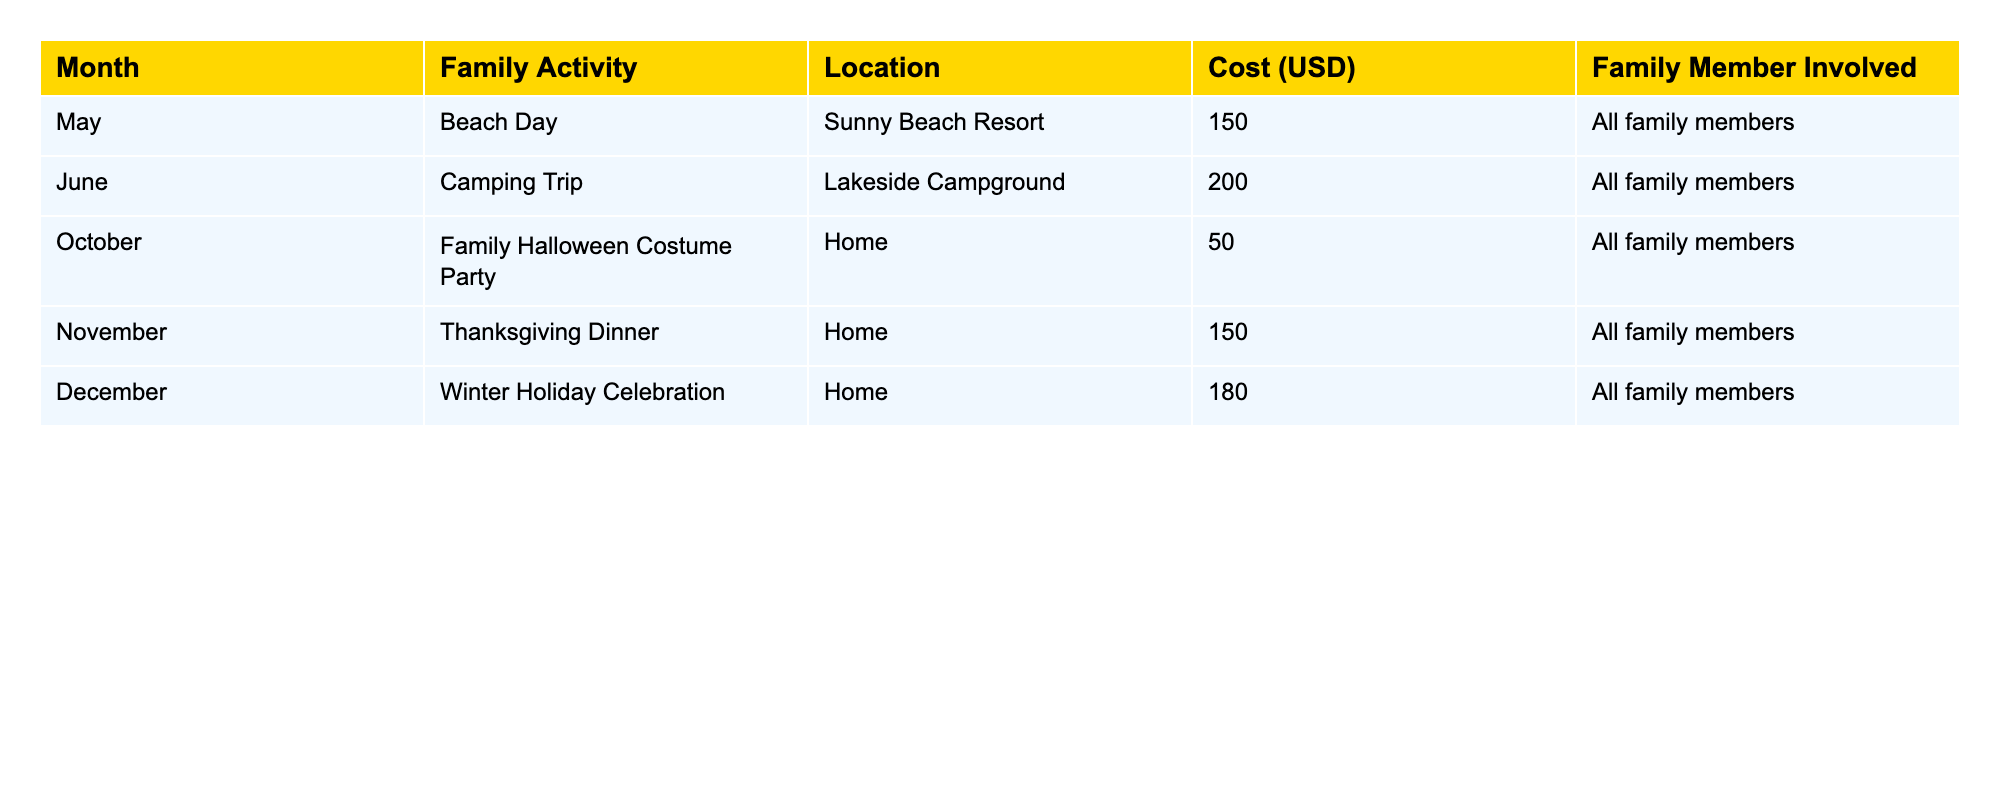What was the cost of the Camping Trip in June? The table indicates the activity for June is "Camping Trip" and the corresponding cost listed is 200 USD.
Answer: 200 USD Which family activity had the lowest cost? The activities and their costs are compared: Beach Day (150 USD), Camping Trip (200 USD), Halloween Costume Party (50 USD), Thanksgiving Dinner (150 USD), and Winter Holiday Celebration (180 USD). The lowest cost is 50 USD for the Halloween Costume Party.
Answer: Halloween Costume Party How much did the family spend in total for the activities in 2023? The individual costs of each activity are summed: 150 + 200 + 50 + 150 + 180 = 730 USD. This is the total expense for the year.
Answer: 730 USD Was there any family activity in December? Yes, according to the table, there is a "Winter Holiday Celebration" listed under December, confirming the existence of a family activity that month.
Answer: Yes What is the average cost of the family activities? To find the average, the total cost is 730 USD (from previous calculation) divided by the number of activities (5), resulting in 730/5 = 146 USD as the average cost per activity.
Answer: 146 USD Which month had the most expensive family activity? Comparing costs: May (150 USD), June (200 USD), October (50 USD), November (150 USD), December (180 USD), we find June's Camping Trip at 200 USD is the highest.
Answer: June Did the family have any activities at home? The table shows both the Halloween Costume Party and the Thanksgiving Dinner occurring at home, indicating that there were activities held there.
Answer: Yes How much more did the family spend on the Winter Holiday Celebration compared to the Halloween Costume Party? The costs for the Winter Holiday Celebration (180 USD) and Halloween Costume Party (50 USD) are compared. Subtracting 50 from 180 gives 130 USD as the difference.
Answer: 130 USD 